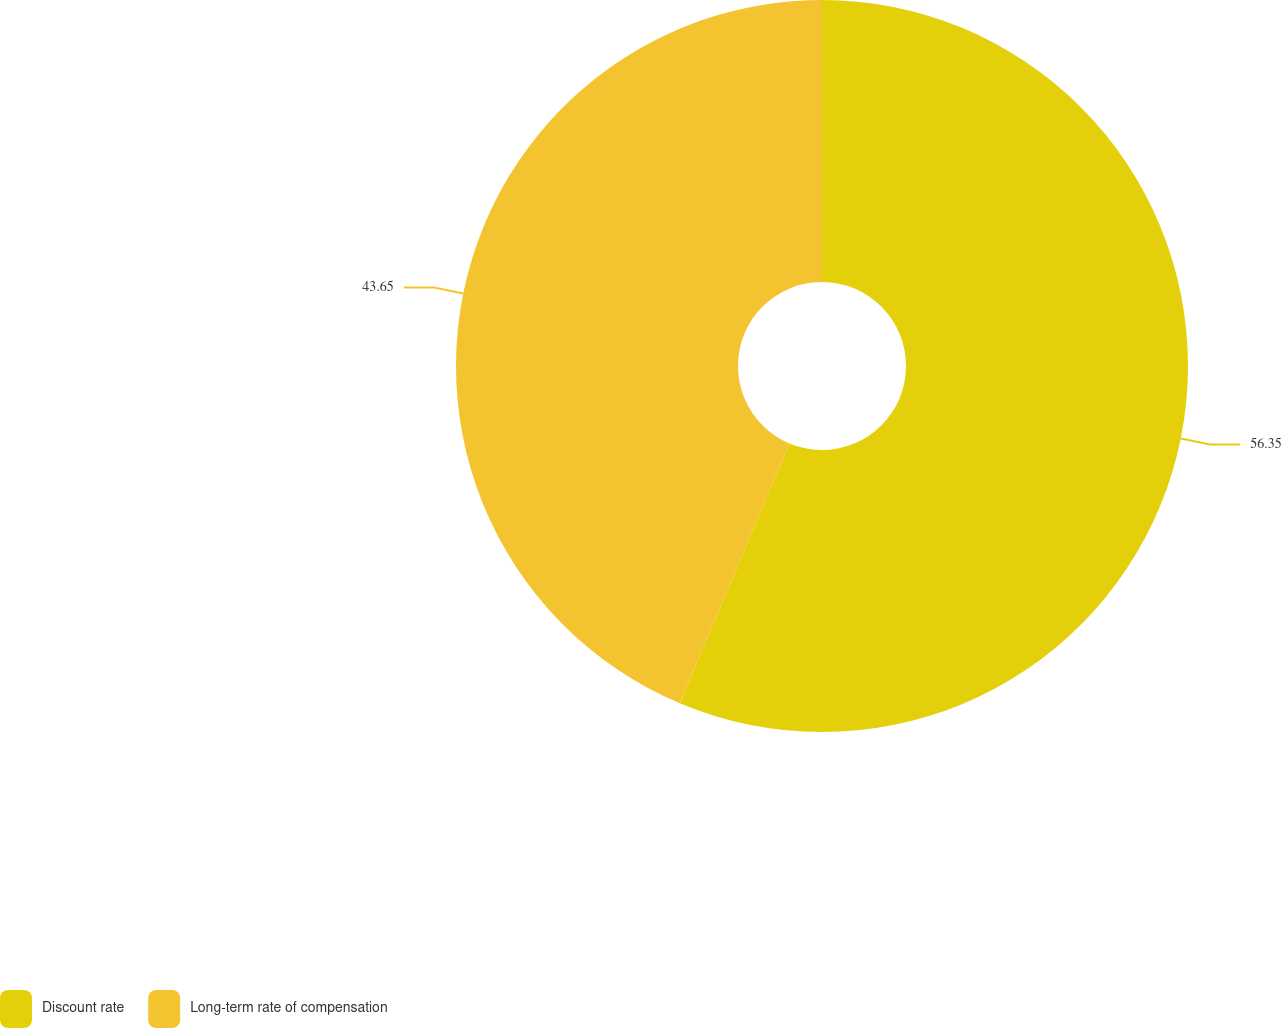<chart> <loc_0><loc_0><loc_500><loc_500><pie_chart><fcel>Discount rate<fcel>Long-term rate of compensation<nl><fcel>56.35%<fcel>43.65%<nl></chart> 